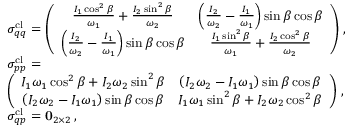Convert formula to latex. <formula><loc_0><loc_0><loc_500><loc_500>\begin{array} { r l } & { \sigma _ { q q } ^ { c l } = \left ( \begin{array} { c c } { \frac { I _ { 1 } \cos ^ { 2 } \beta } { \omega _ { 1 } } + \frac { I _ { 2 } \sin ^ { 2 } \beta } { \omega _ { 2 } } } & { \left ( \frac { I _ { 2 } } { \omega _ { 2 } } - \frac { I _ { 1 } } { \omega _ { 1 } } \right ) \sin \beta \cos \beta } \\ { \left ( \frac { I _ { 2 } } { \omega _ { 2 } } - \frac { I _ { 1 } } { \omega _ { 1 } } \right ) \sin \beta \cos \beta } & { \frac { I _ { 1 } \sin ^ { 2 } \beta } { \omega _ { 1 } } + \frac { I _ { 2 } \cos ^ { 2 } \beta } { \omega _ { 2 } } } \end{array} \right ) \, , } \\ & { \sigma _ { p p } ^ { c l } = } \\ & { \left ( \begin{array} { c c } { I _ { 1 } \omega _ { 1 } \cos ^ { 2 } \beta + I _ { 2 } \omega _ { 2 } \sin ^ { 2 } \beta } & { \left ( I _ { 2 } \omega _ { 2 } - I _ { 1 } \omega _ { 1 } \right ) \sin \beta \cos \beta } \\ { \left ( I _ { 2 } \omega _ { 2 } - I _ { 1 } \omega _ { 1 } \right ) \sin \beta \cos \beta } & { I _ { 1 } \omega _ { 1 } \sin ^ { 2 } \beta + I _ { 2 } \omega _ { 2 } \cos ^ { 2 } \beta } \end{array} \right ) \, , } \\ & { \sigma _ { q p } ^ { c l } = 0 _ { 2 \times 2 } \, , } \end{array}</formula> 